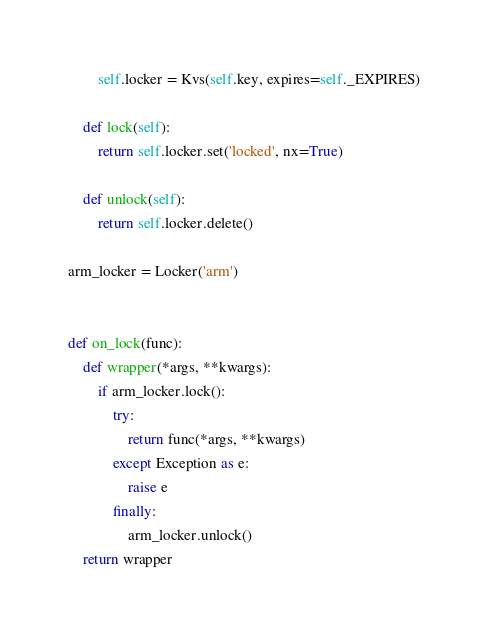Convert code to text. <code><loc_0><loc_0><loc_500><loc_500><_Python_>        self.locker = Kvs(self.key, expires=self._EXPIRES)

    def lock(self):
        return self.locker.set('locked', nx=True)

    def unlock(self):
        return self.locker.delete()

arm_locker = Locker('arm')


def on_lock(func):
    def wrapper(*args, **kwargs):
        if arm_locker.lock():
            try:
                return func(*args, **kwargs)
            except Exception as e:
                raise e
            finally:
                arm_locker.unlock()
    return wrapper
</code> 